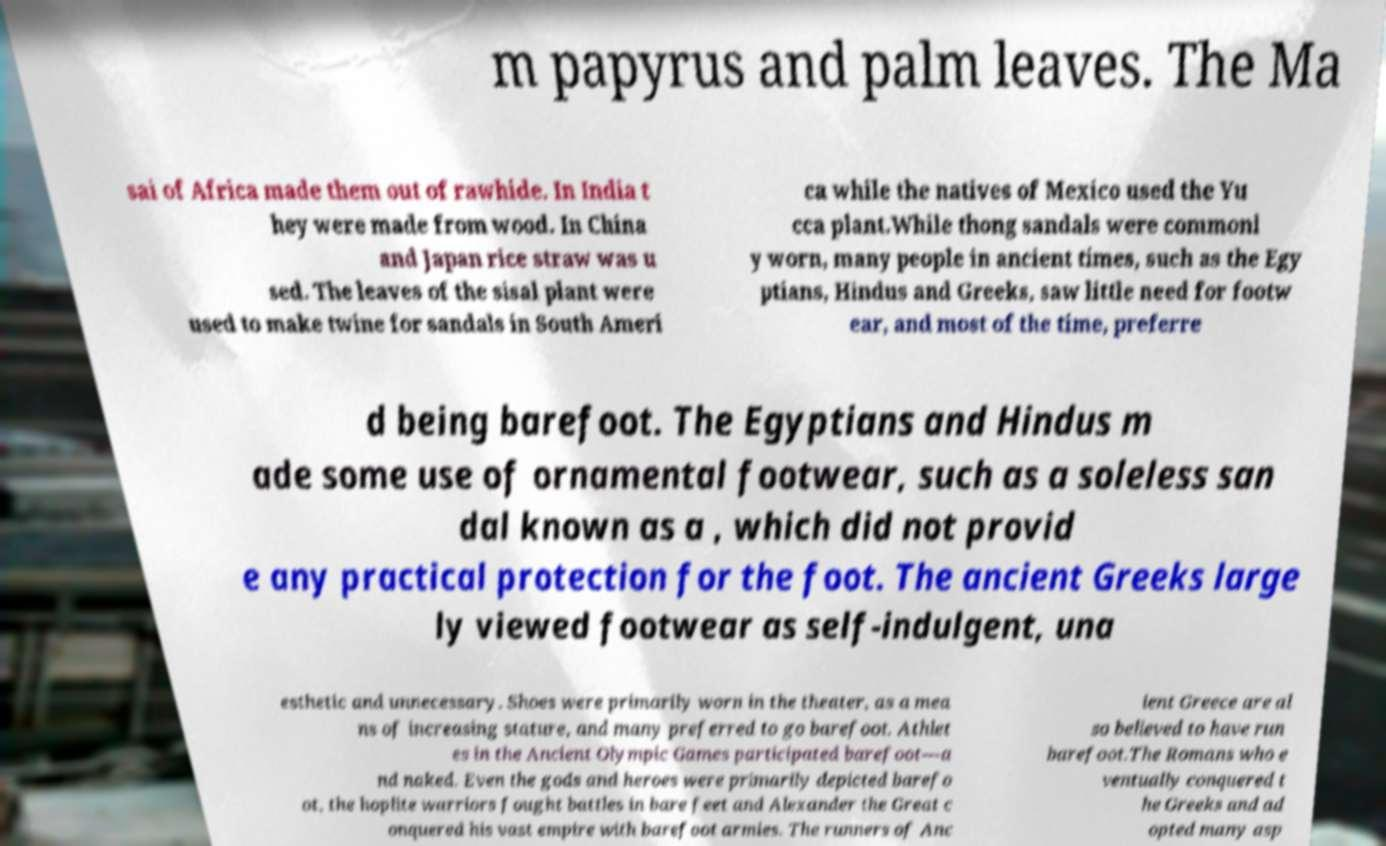Can you read and provide the text displayed in the image?This photo seems to have some interesting text. Can you extract and type it out for me? m papyrus and palm leaves. The Ma sai of Africa made them out of rawhide. In India t hey were made from wood. In China and Japan rice straw was u sed. The leaves of the sisal plant were used to make twine for sandals in South Ameri ca while the natives of Mexico used the Yu cca plant.While thong sandals were commonl y worn, many people in ancient times, such as the Egy ptians, Hindus and Greeks, saw little need for footw ear, and most of the time, preferre d being barefoot. The Egyptians and Hindus m ade some use of ornamental footwear, such as a soleless san dal known as a , which did not provid e any practical protection for the foot. The ancient Greeks large ly viewed footwear as self-indulgent, una esthetic and unnecessary. Shoes were primarily worn in the theater, as a mea ns of increasing stature, and many preferred to go barefoot. Athlet es in the Ancient Olympic Games participated barefoot—a nd naked. Even the gods and heroes were primarily depicted barefo ot, the hoplite warriors fought battles in bare feet and Alexander the Great c onquered his vast empire with barefoot armies. The runners of Anc ient Greece are al so believed to have run barefoot.The Romans who e ventually conquered t he Greeks and ad opted many asp 